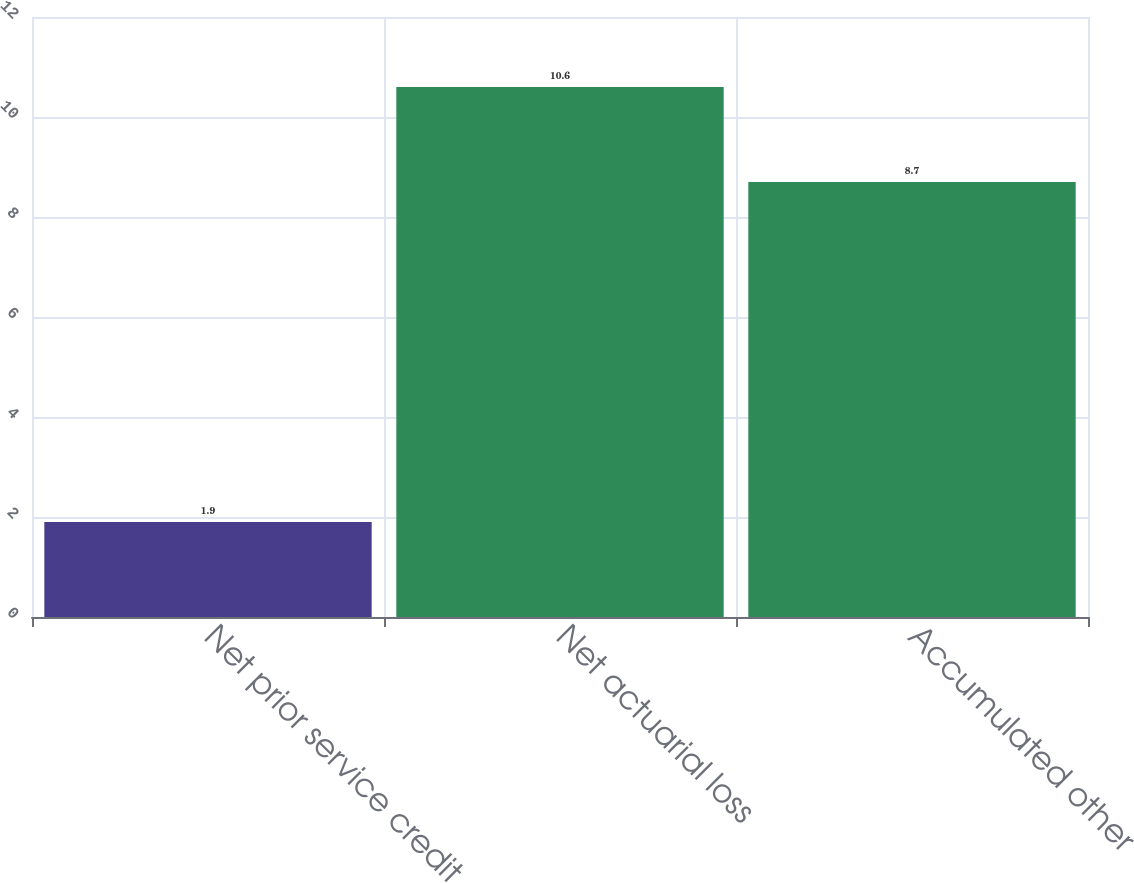Convert chart to OTSL. <chart><loc_0><loc_0><loc_500><loc_500><bar_chart><fcel>Net prior service credit<fcel>Net actuarial loss<fcel>Accumulated other<nl><fcel>1.9<fcel>10.6<fcel>8.7<nl></chart> 